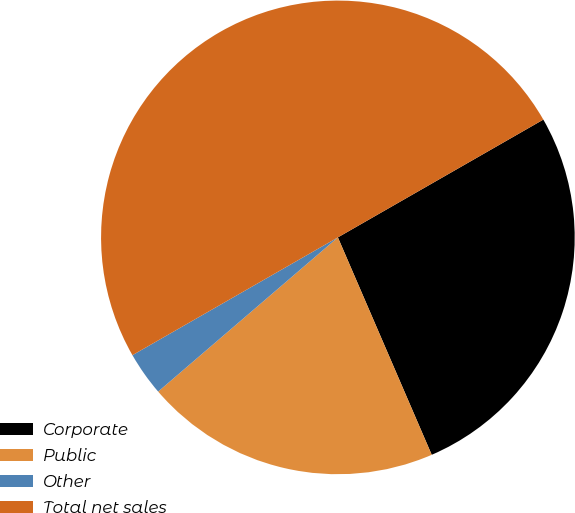Convert chart to OTSL. <chart><loc_0><loc_0><loc_500><loc_500><pie_chart><fcel>Corporate<fcel>Public<fcel>Other<fcel>Total net sales<nl><fcel>26.8%<fcel>20.2%<fcel>3.0%<fcel>50.0%<nl></chart> 